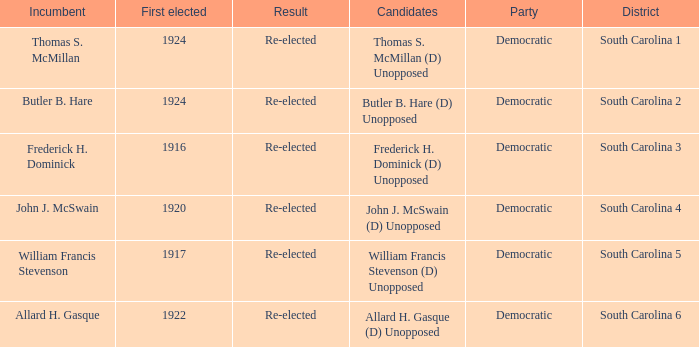What is the result for south carolina 4? Re-elected. 